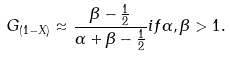<formula> <loc_0><loc_0><loc_500><loc_500>G _ { ( 1 - X ) } \approx { \frac { \beta - { \frac { 1 } { 2 } } } { \alpha + \beta - { \frac { 1 } { 2 } } } } { i f } \alpha , \beta > 1 .</formula> 